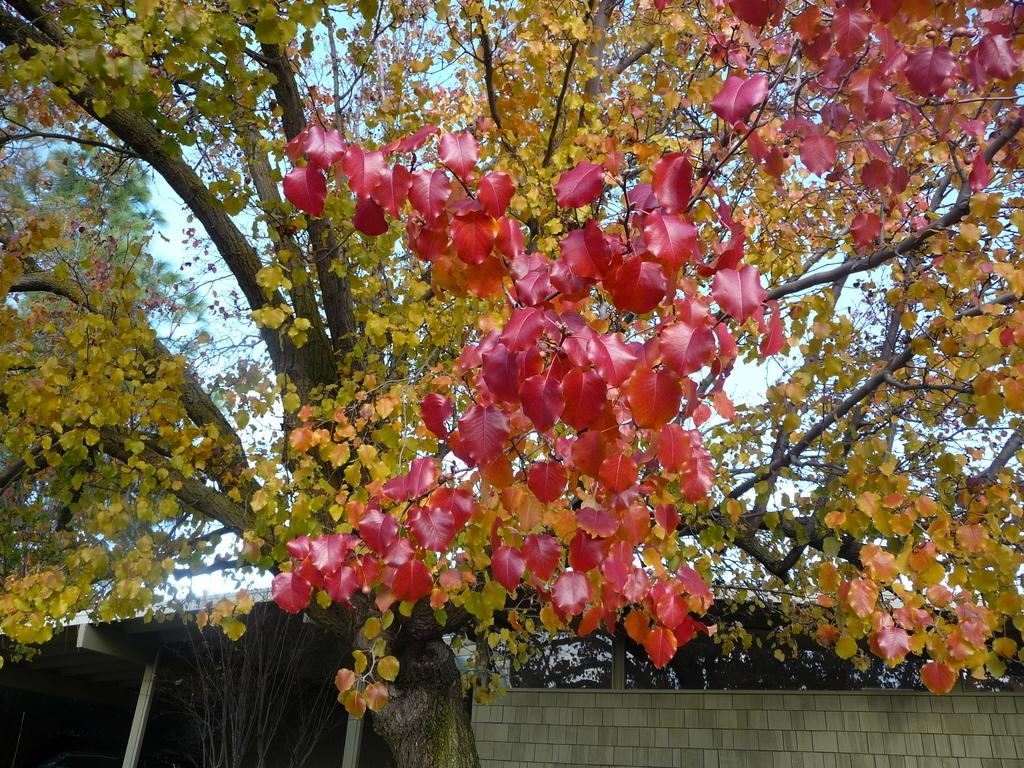What color are the flowers in the image? The flowers in the image are red. What can be seen in the background of the image? There are trees in green color and the sky in white color in the background of the image. What type of holiday is being celebrated in the image? There is no indication of a holiday being celebrated in the image. Can you see a basket filled with fruits in the image? There is no basket or fruits present in the image. 